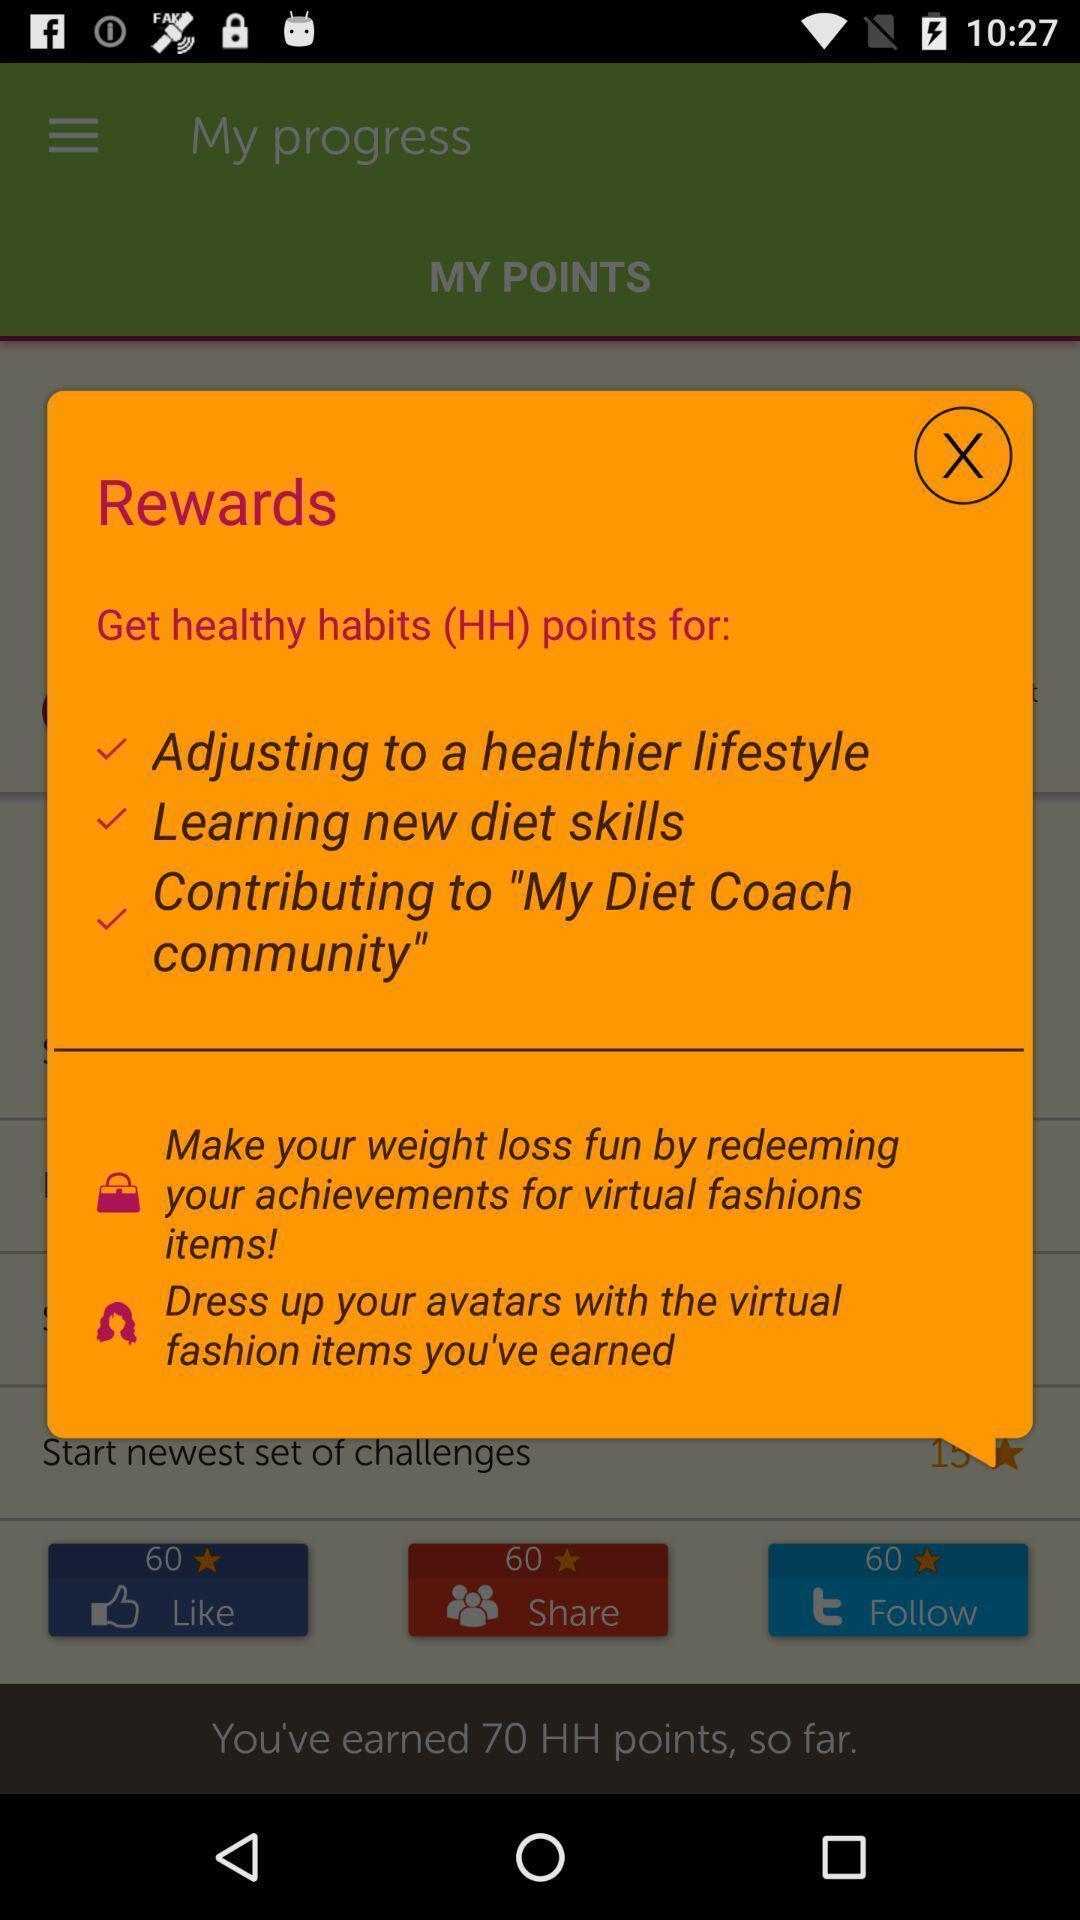Please provide a description for this image. Popup window is showing rewards. 